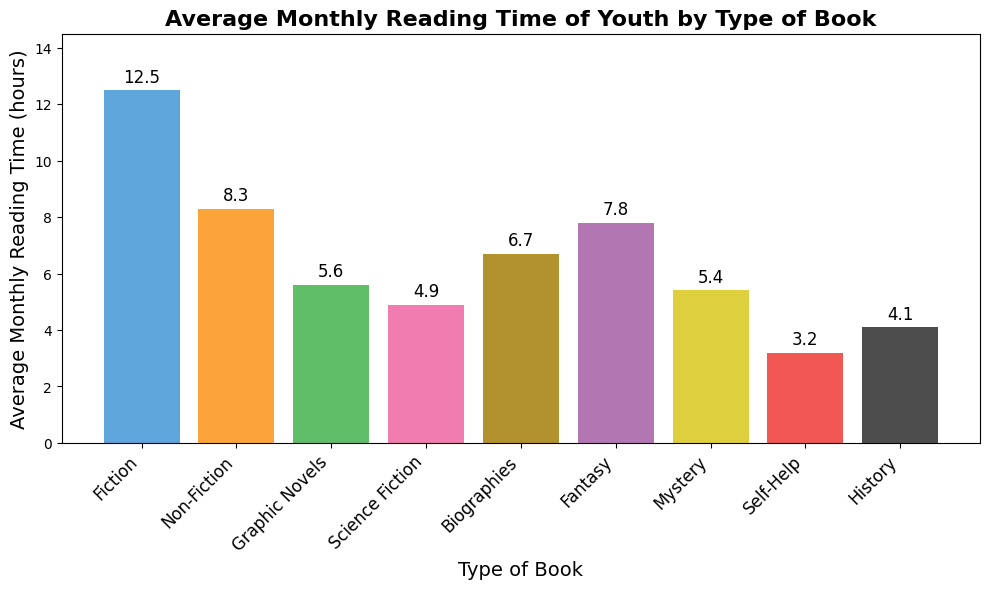Which type of book has the highest average monthly reading time? Examine the height of each bar and identify the tallest one. The bar that represents Fiction is the tallest with a reading time of 12.5 hours.
Answer: Fiction Which type of book has the lowest average monthly reading time? Examine the height of each bar and identify the shortest one. The bar that represents Self-Help is the shortest with a reading time of 3.2 hours.
Answer: Self-Help What is the difference in average monthly reading time between Fiction and Non-Fiction? Locate the heights of the bars for Fiction and Non-Fiction, which are 12.5 and 8.3 hours respectively. Subtract the Non-Fiction value from the Fiction value: 12.5 - 8.3 = 4.2 hours.
Answer: 4.2 hours Which type of book has a higher average monthly reading time: Fantasy or Science Fiction? Compare the height of the bars for Fantasy and Science Fiction. The Fantasy bar is 7.8 hours, and the Science Fiction bar is 4.9 hours. Fantasy has a higher average reading time.
Answer: Fantasy What is the total average monthly reading time for Graphic Novels and Biographies combined? Locate the height of the bars for Graphic Novels and Biographies, which are 5.6 and 6.7 hours respectively. Sum these values: 5.6 + 6.7 = 12.3 hours.
Answer: 12.3 hours What is the average monthly reading time across all types of books? First, sum the average reading times for all types of books: 12.5 + 8.3 + 5.6 + 4.9 + 6.7 + 7.8 + 5.4 + 3.2 + 4.1 = 58.5 hours. Then, divide by the number of book types, which is 9: 58.5 / 9 ≈ 6.5 hours.
Answer: 6.5 hours Which color represents the Mystery books in the chart? Identify the color of the bar labeled Mystery. The Mystery bar is represented by a yellow color.
Answer: Yellow How much more time do youths spend reading Fiction compared to Fantasy? Locate the height of the bars for Fiction and Fantasy, which are 12.5 and 7.8 hours respectively. Subtract the Fantasy value from the Fiction value: 12.5 - 7.8 = 4.7 hours.
Answer: 4.7 hours Is the average monthly reading time for Biographies more than or less than twice that of Science Fiction? Double the reading time for Science Fiction, which is 4.9 hours: 2 * 4.9 = 9.8 hours. Compare this with the reading time for Biographies, which is 6.7 hours. Since 6.7 is less than 9.8, it is less than twice the reading time of Science Fiction.
Answer: Less than 